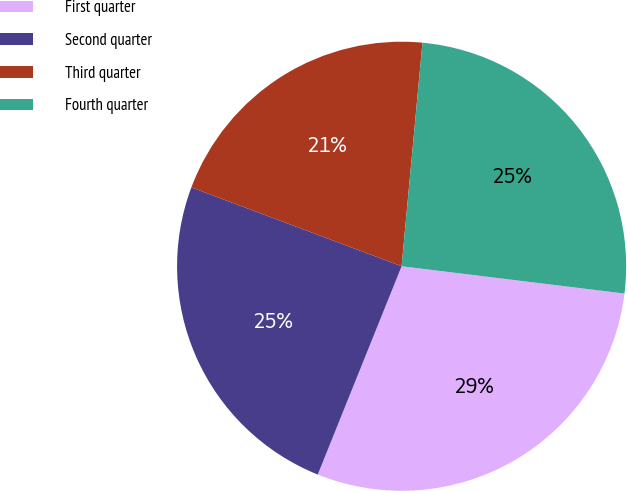Convert chart. <chart><loc_0><loc_0><loc_500><loc_500><pie_chart><fcel>First quarter<fcel>Second quarter<fcel>Third quarter<fcel>Fourth quarter<nl><fcel>29.15%<fcel>24.62%<fcel>20.77%<fcel>25.46%<nl></chart> 